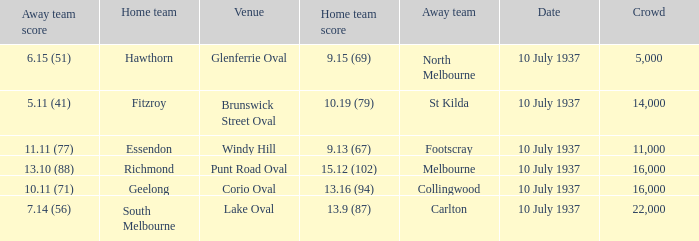What was the Venue of the North Melbourne Away Team? Glenferrie Oval. 